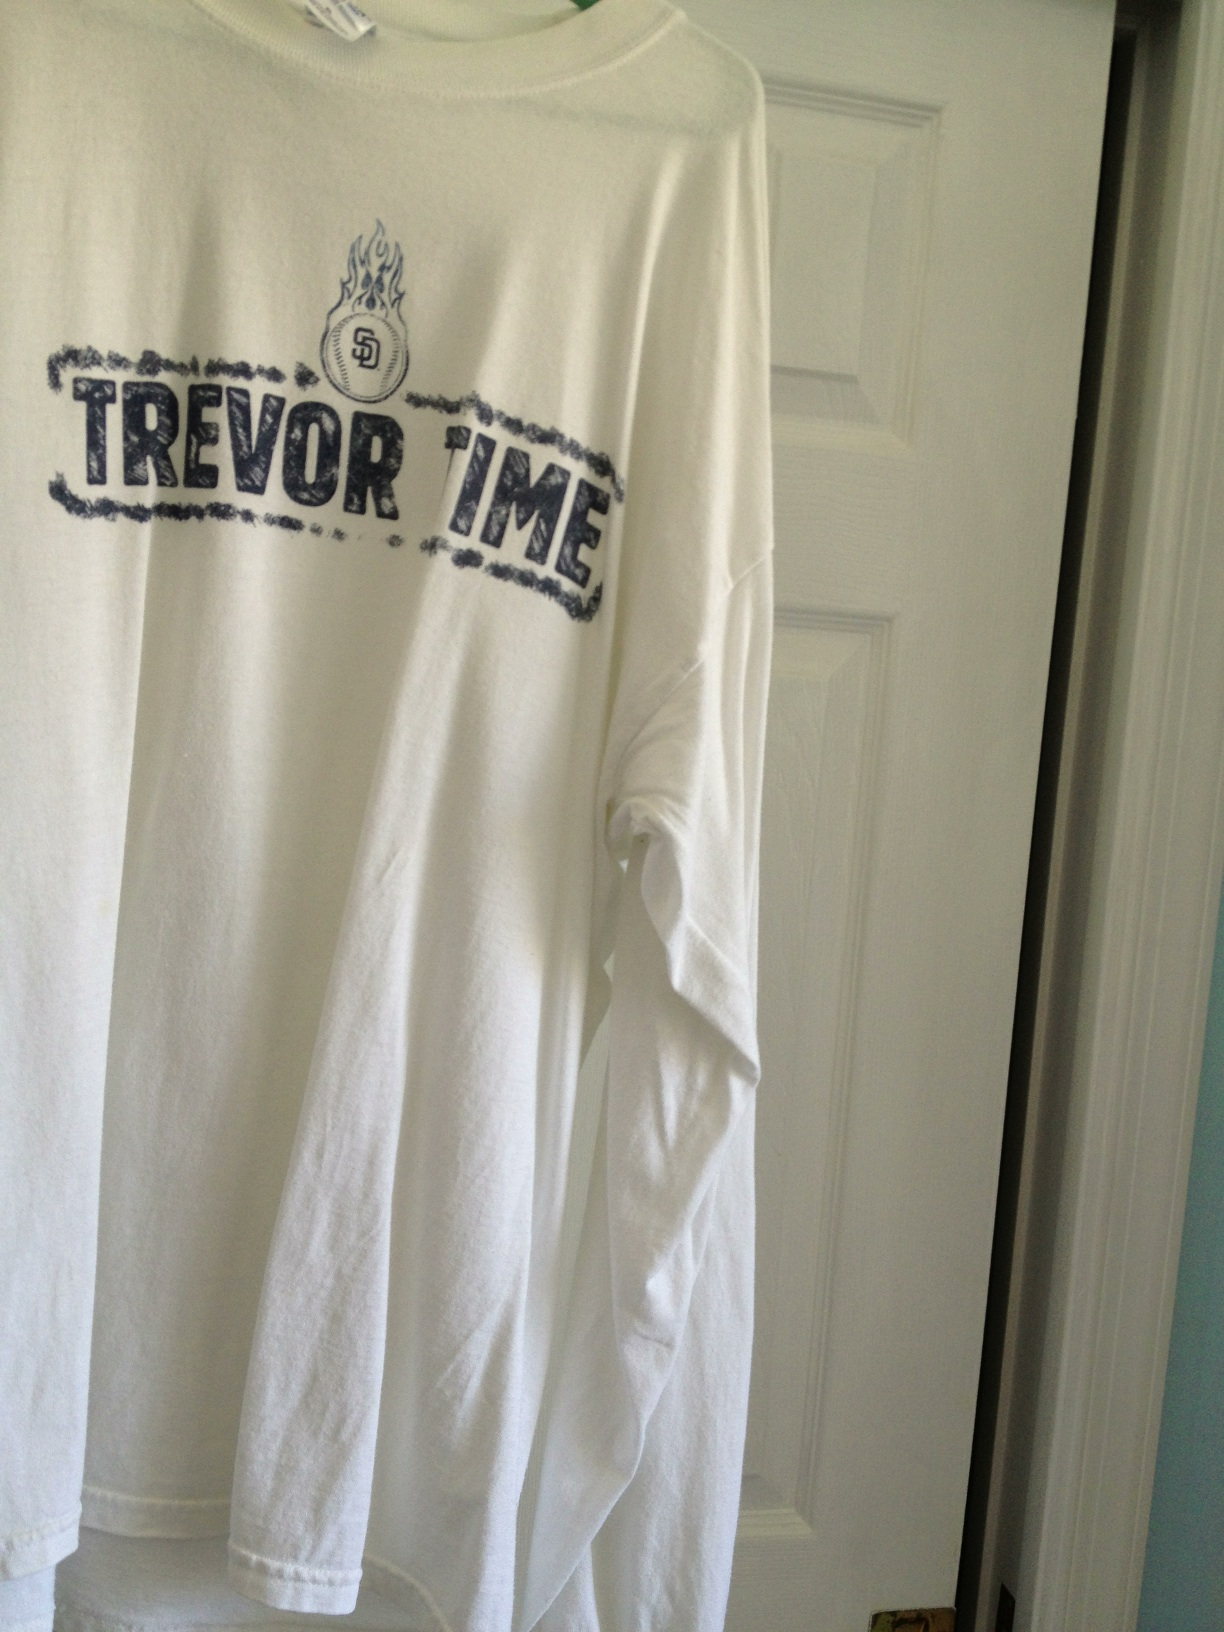What shirt is this? This is a white long-sleeve shirt with the phrase 'TREVOЯ TIME' printed on it, along with a baseball and flame graphic associated with the San Diego Padres. It is a tribute to a significant event or player related to the team. 